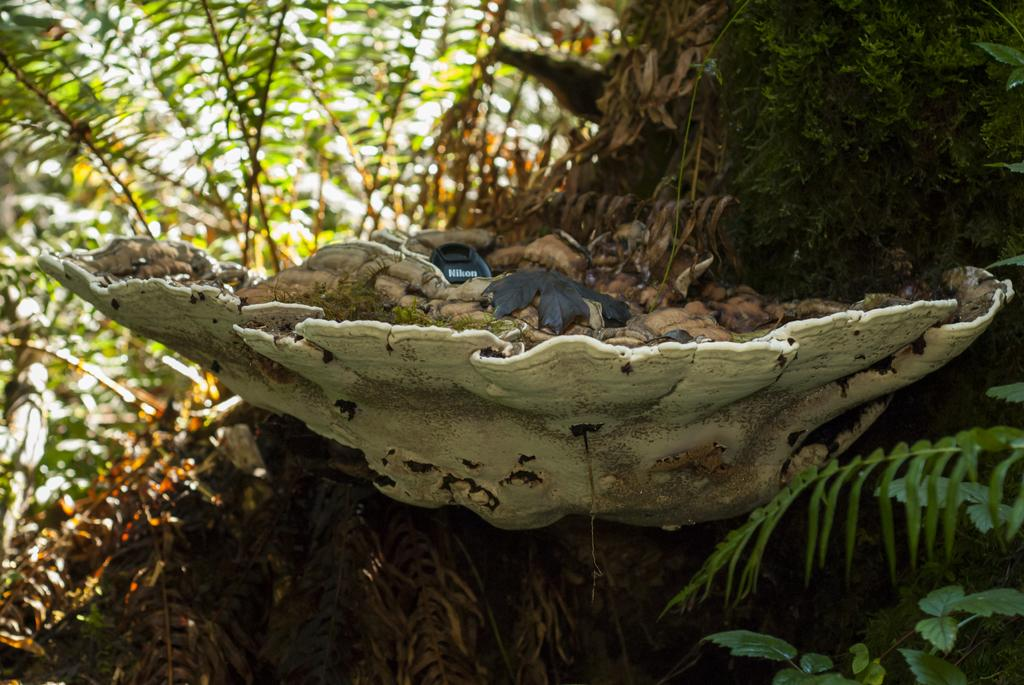What type of natural object can be seen in the image? There is a tree in the image. What is the net-like structure with dried leaves in the image? It is a net-like structure with dried leaves, possibly a spider web or similar natural formation. What item related to photography is present in the image? A Nikon camera lens cover is present in the image. What other types of vegetation can be seen in the image? There are plants visible behind the tree. What type of boat is depicted in the image? There is no boat present in the image. How does the calculator help with the religious practices in the image? There is no calculator or reference to religious practices in the image. 